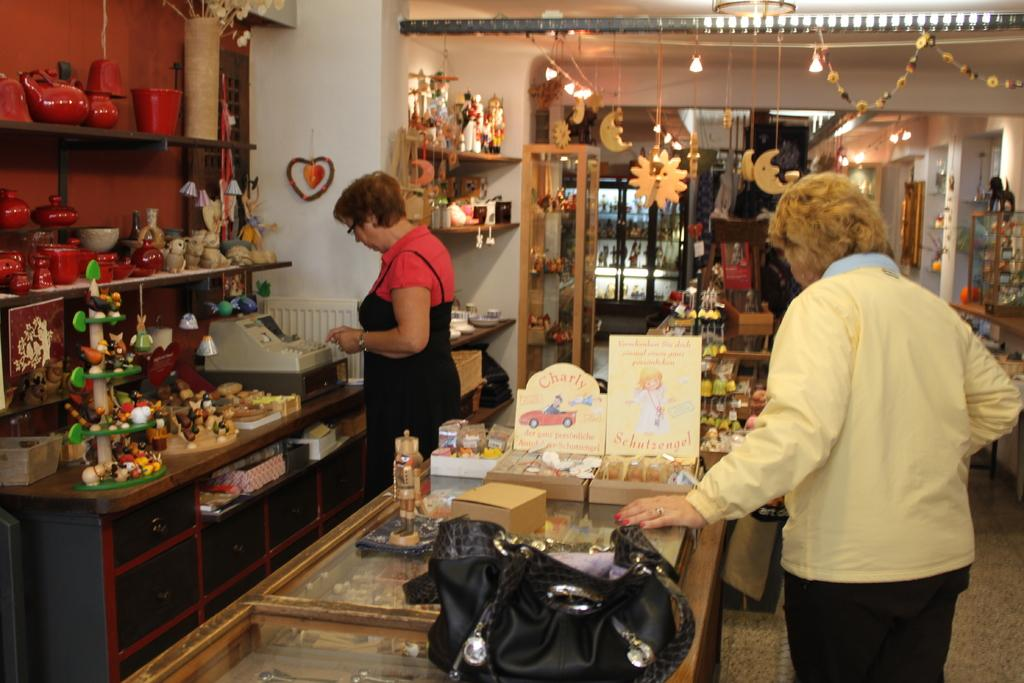How many people are present in the image? There are two persons standing in the image. What is the main object in the image besides the people? There is a table in the image. What can be found on the table? There are objects on the table. What type of jewel is being used as a fingerprint scanner in the image? There is no fingerprint scanner or jewel present in the image. 